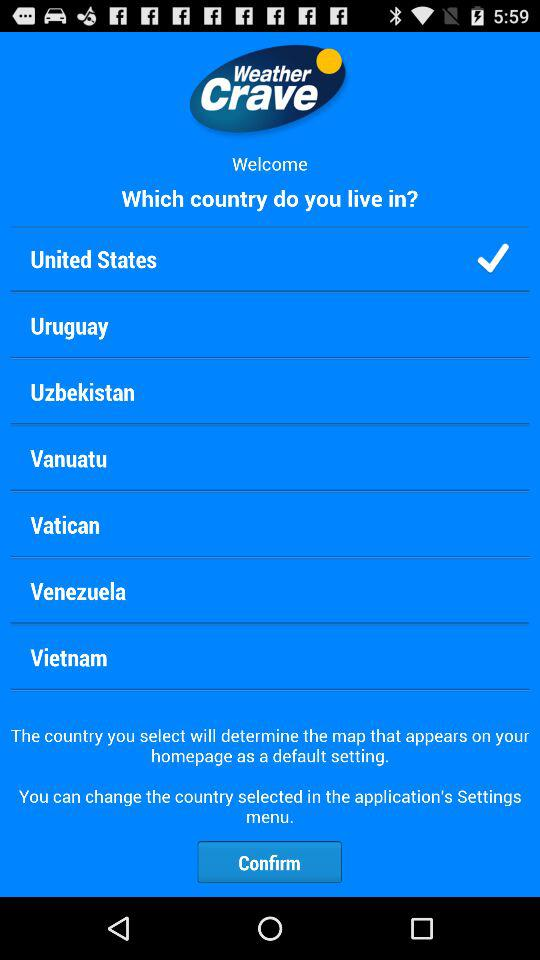What is the application name? The application name is "Weather Crave". 